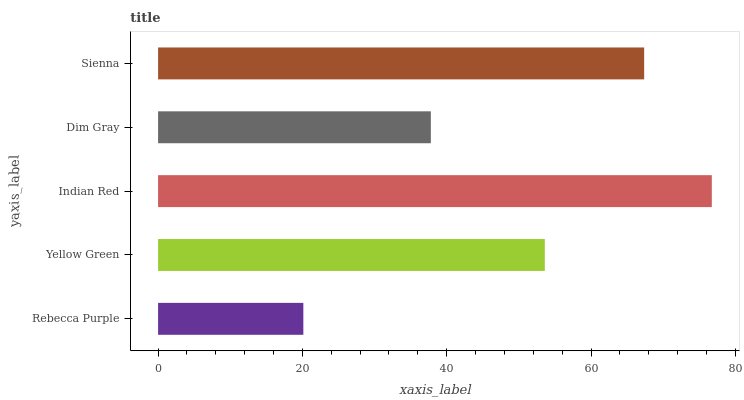Is Rebecca Purple the minimum?
Answer yes or no. Yes. Is Indian Red the maximum?
Answer yes or no. Yes. Is Yellow Green the minimum?
Answer yes or no. No. Is Yellow Green the maximum?
Answer yes or no. No. Is Yellow Green greater than Rebecca Purple?
Answer yes or no. Yes. Is Rebecca Purple less than Yellow Green?
Answer yes or no. Yes. Is Rebecca Purple greater than Yellow Green?
Answer yes or no. No. Is Yellow Green less than Rebecca Purple?
Answer yes or no. No. Is Yellow Green the high median?
Answer yes or no. Yes. Is Yellow Green the low median?
Answer yes or no. Yes. Is Rebecca Purple the high median?
Answer yes or no. No. Is Dim Gray the low median?
Answer yes or no. No. 